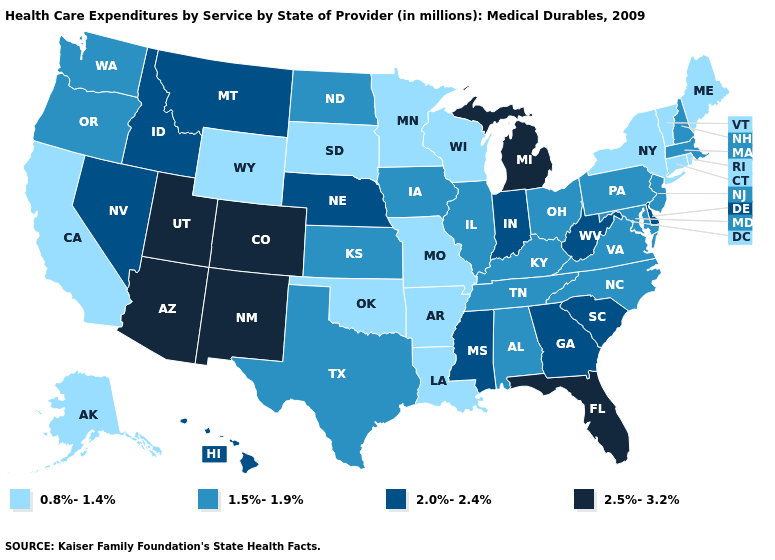Which states have the lowest value in the South?
Concise answer only. Arkansas, Louisiana, Oklahoma. Is the legend a continuous bar?
Give a very brief answer. No. Name the states that have a value in the range 0.8%-1.4%?
Give a very brief answer. Alaska, Arkansas, California, Connecticut, Louisiana, Maine, Minnesota, Missouri, New York, Oklahoma, Rhode Island, South Dakota, Vermont, Wisconsin, Wyoming. Name the states that have a value in the range 0.8%-1.4%?
Quick response, please. Alaska, Arkansas, California, Connecticut, Louisiana, Maine, Minnesota, Missouri, New York, Oklahoma, Rhode Island, South Dakota, Vermont, Wisconsin, Wyoming. Which states hav the highest value in the West?
Keep it brief. Arizona, Colorado, New Mexico, Utah. What is the value of Missouri?
Give a very brief answer. 0.8%-1.4%. What is the highest value in the Northeast ?
Be succinct. 1.5%-1.9%. What is the value of South Dakota?
Answer briefly. 0.8%-1.4%. Does Nebraska have the lowest value in the USA?
Concise answer only. No. What is the value of Delaware?
Concise answer only. 2.0%-2.4%. Name the states that have a value in the range 2.0%-2.4%?
Be succinct. Delaware, Georgia, Hawaii, Idaho, Indiana, Mississippi, Montana, Nebraska, Nevada, South Carolina, West Virginia. Among the states that border Minnesota , does North Dakota have the highest value?
Answer briefly. Yes. Does the first symbol in the legend represent the smallest category?
Give a very brief answer. Yes. What is the highest value in states that border Vermont?
Keep it brief. 1.5%-1.9%. Does the first symbol in the legend represent the smallest category?
Give a very brief answer. Yes. 